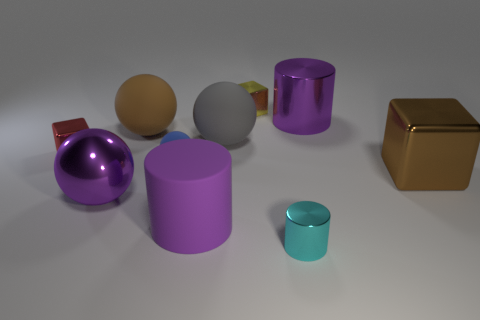Subtract all purple balls. How many balls are left? 3 Subtract all small cubes. How many cubes are left? 1 Subtract all yellow spheres. Subtract all yellow cubes. How many spheres are left? 4 Subtract all cylinders. How many objects are left? 7 Add 3 big cylinders. How many big cylinders are left? 5 Add 3 small brown cubes. How many small brown cubes exist? 3 Subtract 0 brown cylinders. How many objects are left? 10 Subtract all big purple cylinders. Subtract all large blue metal objects. How many objects are left? 8 